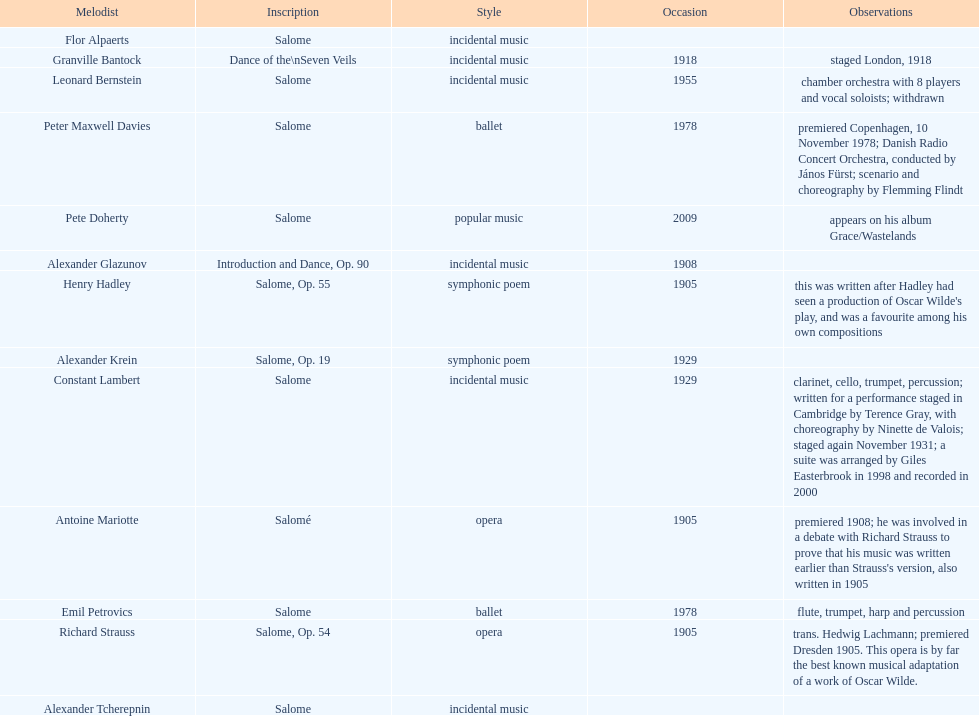What is the number of works titled "salome?" 11. 